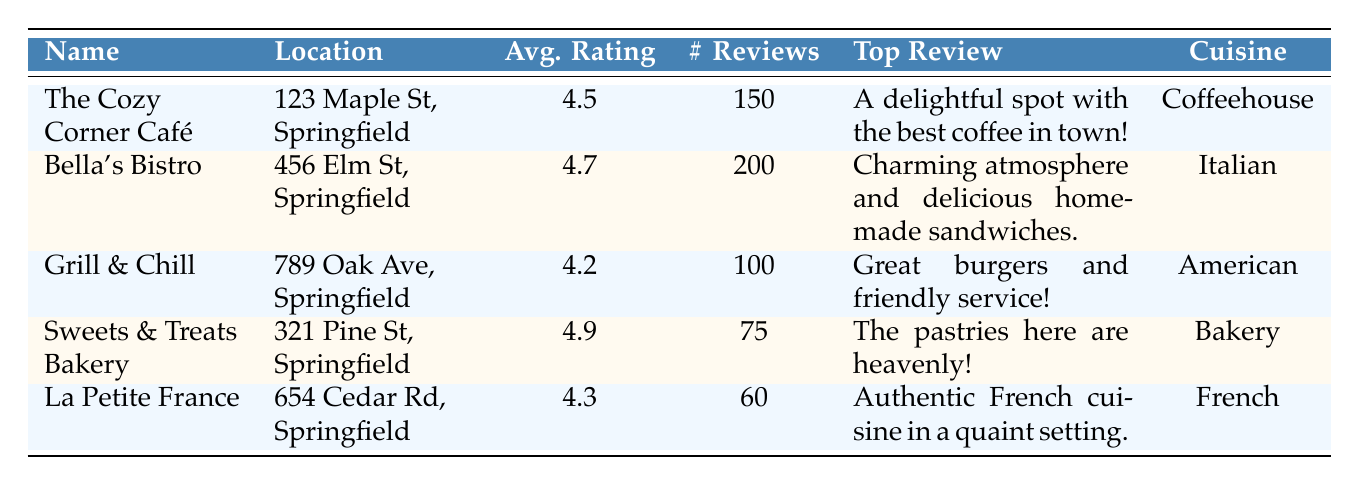What is the average rating of Sweets & Treats Bakery? The average rating for Sweets & Treats Bakery is provided directly in the table, which is 4.9.
Answer: 4.9 Which café has the highest number of reviews? By looking at the number of reviews for each establishment, Bella's Bistro has the highest with 200 reviews, compared to others.
Answer: Bella's Bistro How many cafés and restaurants have an average rating above 4.4? Checking the average ratings, The Cozy Corner Café (4.5), Bella's Bistro (4.7), and Sweets & Treats Bakery (4.9) all have ratings above 4.4. Thus, there are three establishments meeting this criterion.
Answer: 3 Is it true that La Petite France has fewer reviews than Grill & Chill? La Petite France has 60 reviews while Grill & Chill has 100 reviews. Since 60 is less than 100, the statement is true.
Answer: Yes What is the average number of reviews across all cafés and restaurants listed? To find the average, sum all the reviews: 150 + 200 + 100 + 75 + 60 = 585. There are 5 entries, so the average is 585/5 = 117.
Answer: 117 Which cuisine type has the lowest average rating? Grill & Chill (American) has an average rating of 4.2, which is lower than the other categories.
Answer: American What is the top review for Bella's Bistro? The top review for Bella's Bistro, as shown in the table, is "Charming atmosphere and delicious homemade sandwiches."
Answer: Charming atmosphere and delicious homemade sandwiches Which establishment offers the highest average rating, and what is its cuisine type? Sweets & Treats Bakery has the highest average rating of 4.9, and its cuisine type is Bakery.
Answer: Sweets & Treats Bakery, Bakery How would you describe the overall sentiment of customer reviews for the establishments listed? The reviews presented are all positive, indicating a generally favorable sentiment across all establishments in terms of atmosphere, service, and food quality.
Answer: Generally positive 